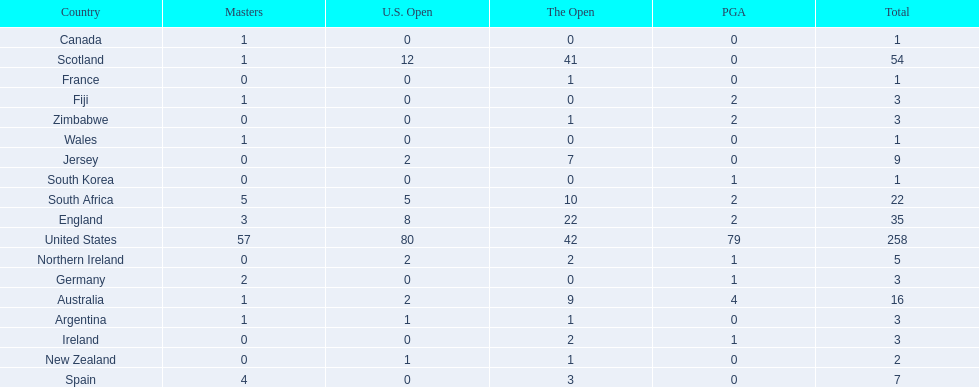Which of the countries listed are african? South Africa, Zimbabwe. Which of those has the least championship winning golfers? Zimbabwe. 